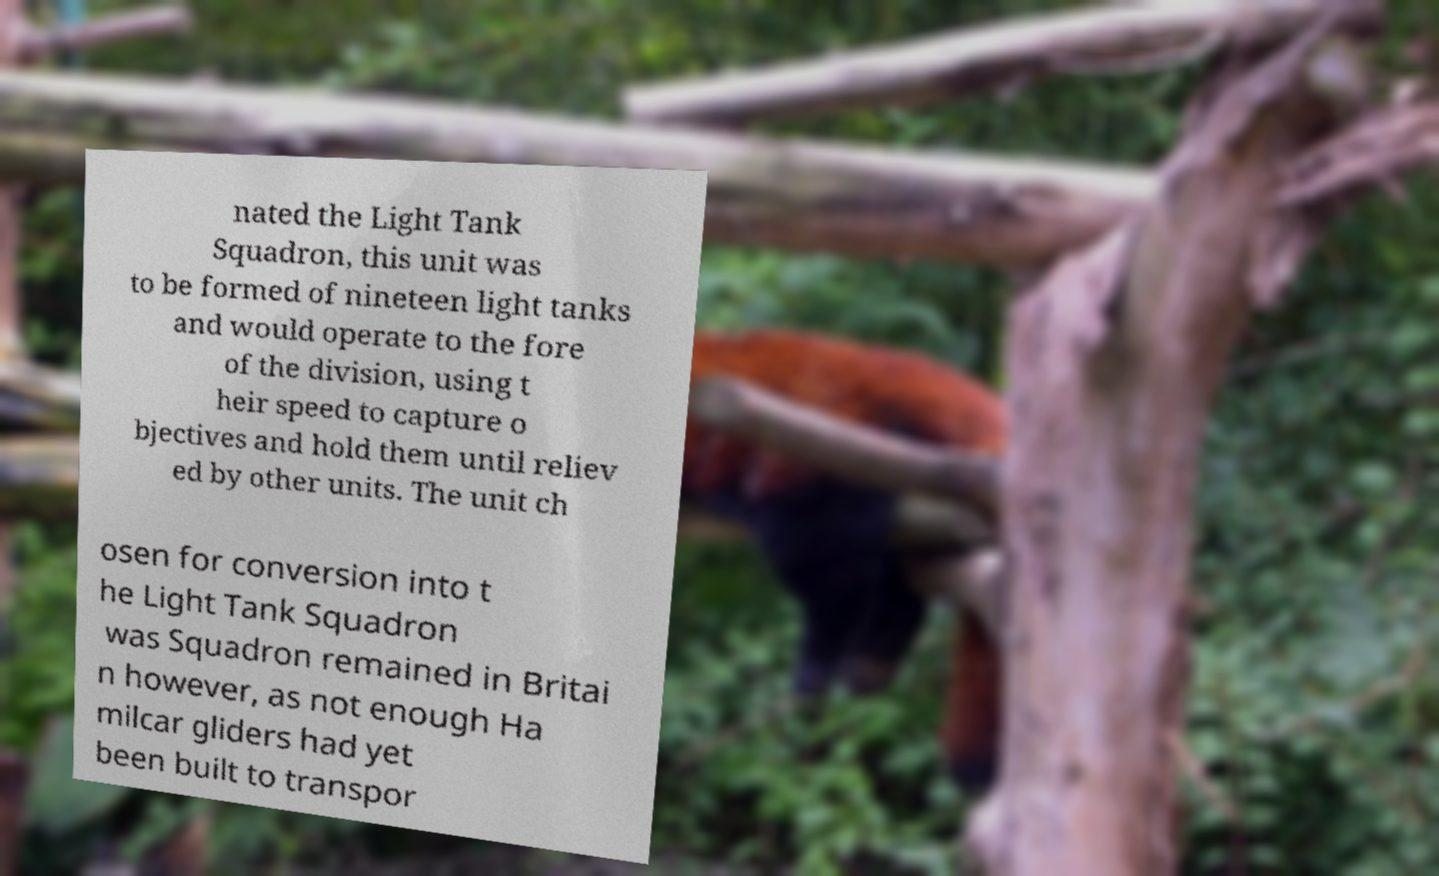Can you read and provide the text displayed in the image?This photo seems to have some interesting text. Can you extract and type it out for me? nated the Light Tank Squadron, this unit was to be formed of nineteen light tanks and would operate to the fore of the division, using t heir speed to capture o bjectives and hold them until reliev ed by other units. The unit ch osen for conversion into t he Light Tank Squadron was Squadron remained in Britai n however, as not enough Ha milcar gliders had yet been built to transpor 